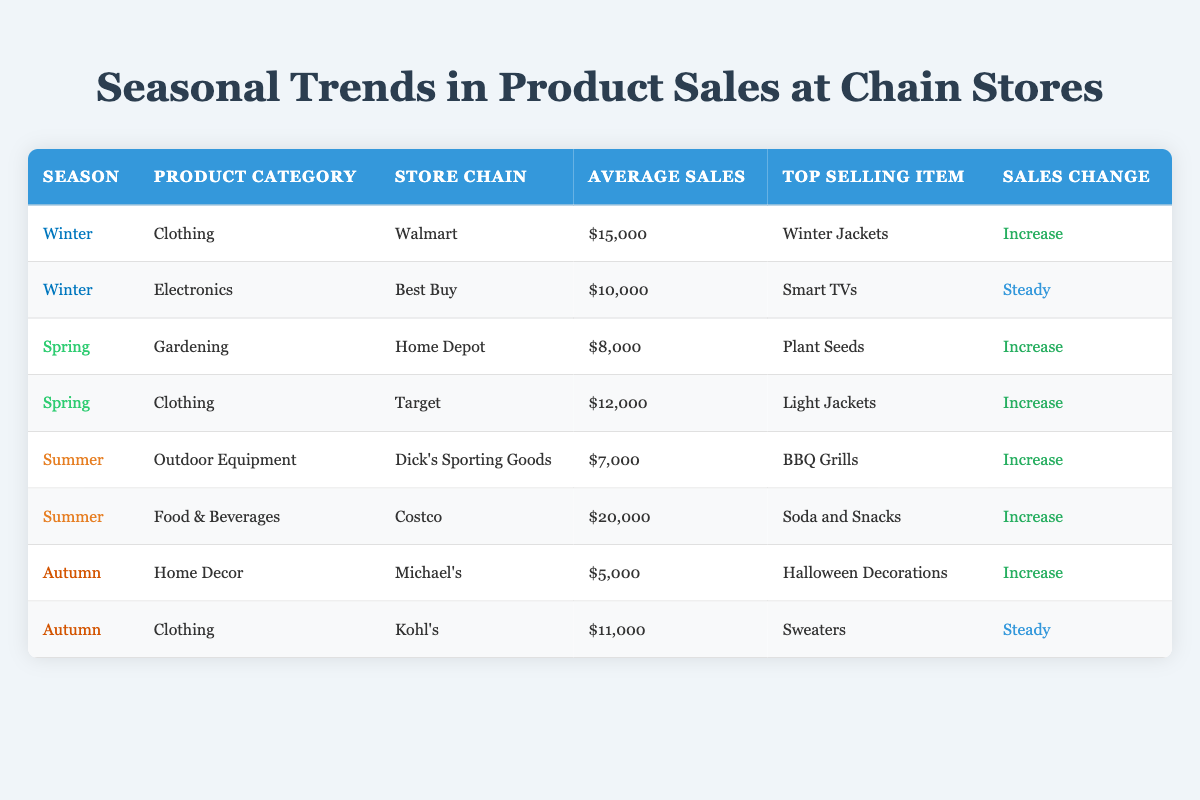What is the top selling item for Winter in Walmart? Referring to the table, the row corresponding to Winter in Walmart indicates that the top selling item is "Winter Jackets."
Answer: Winter Jackets Which store chain has the highest average sales in Summer? Looking at the Summer data, Costco shows an average sales of $20,000, while Dick's Sporting Goods indicates $7,000. Therefore, Costco has the highest average sales.
Answer: Costco How many product categories show an increase in sales across all seasons? By reviewing the sales change column, we identify that four categories show an increase: Clothing in Winter, Gardening in Spring, Outdoor Equipment in Summer, and Home Decor in Autumn. Thus, there are four categories with sales increase.
Answer: 4 Is there any product category in Autumn that maintains steady sales? Checking the Autumn section, we find that the Clothing category in Kohl's has steady sales. Therefore, yes, there is one product category with steady sales during Autumn.
Answer: Yes What is the difference in average sales between the top selling item in Summer and the one in Autumn? The top selling item in Summer is from Costco with $20,000, while the top selling item in Autumn from Michael's shows $5,000. The difference is calculated as $20,000 - $5,000 = $15,000.
Answer: 15000 